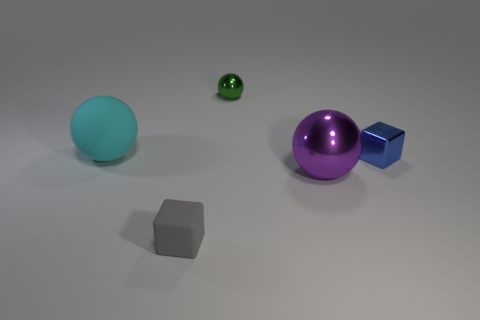Subtract all green metallic balls. How many balls are left? 2 Subtract 1 blocks. How many blocks are left? 1 Subtract all green balls. How many balls are left? 2 Subtract all balls. How many objects are left? 2 Add 3 purple balls. How many objects exist? 8 Subtract all green cylinders. How many gray blocks are left? 1 Subtract all tiny metal balls. Subtract all gray objects. How many objects are left? 3 Add 3 green shiny spheres. How many green shiny spheres are left? 4 Add 2 gray rubber cubes. How many gray rubber cubes exist? 3 Subtract 1 blue cubes. How many objects are left? 4 